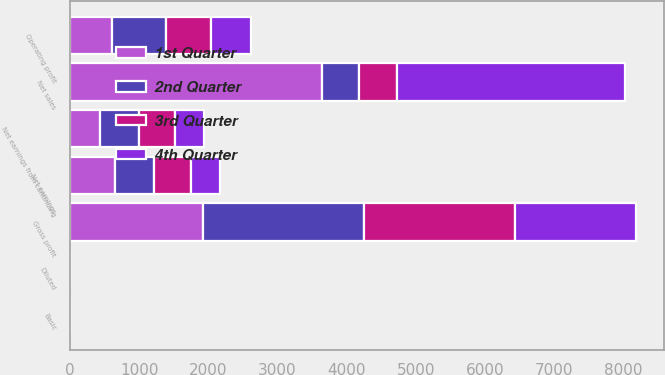<chart> <loc_0><loc_0><loc_500><loc_500><stacked_bar_chart><ecel><fcel>Net sales<fcel>Gross profit<fcel>Operating profit<fcel>Net earnings from continuing<fcel>Net earnings<fcel>Basic<fcel>Diluted<nl><fcel>4th Quarter<fcel>3292.2<fcel>1748.9<fcel>584.9<fcel>416.8<fcel>429.4<fcel>0.63<fcel>0.63<nl><fcel>1st Quarter<fcel>3635.9<fcel>1917.6<fcel>610<fcel>439.6<fcel>648.8<fcel>0.66<fcel>0.94<nl><fcel>3rd Quarter<fcel>543.45<fcel>2183.1<fcel>643.1<fcel>515.4<fcel>523.4<fcel>0.75<fcel>0.74<nl><fcel>2nd Quarter<fcel>543.45<fcel>2327.1<fcel>779.2<fcel>563.5<fcel>570.7<fcel>0.82<fcel>0.8<nl></chart> 